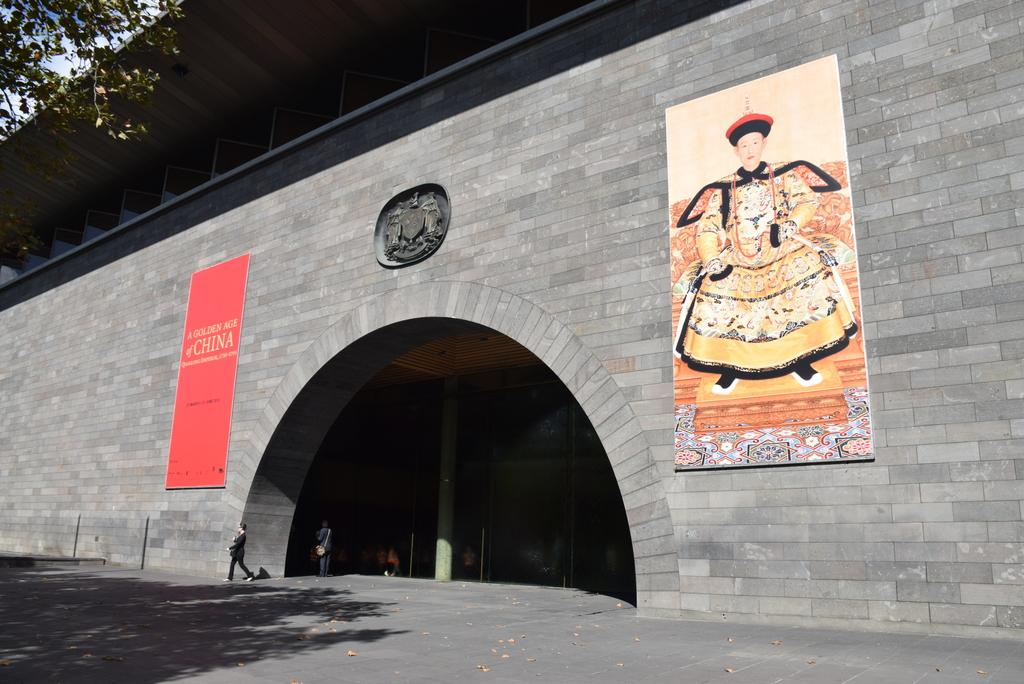What is hanging on the wall in the image? There are photo frames on the wall. What type of natural element can be seen in the image? There is a tree in the image. What is one person doing in the image? A person is walking in the image. What is another person doing in the image? Another person is standing in the image. What territory is being claimed by the person standing in the image? There is no indication in the image that a territory is being claimed, and no such information is provided in the facts. 